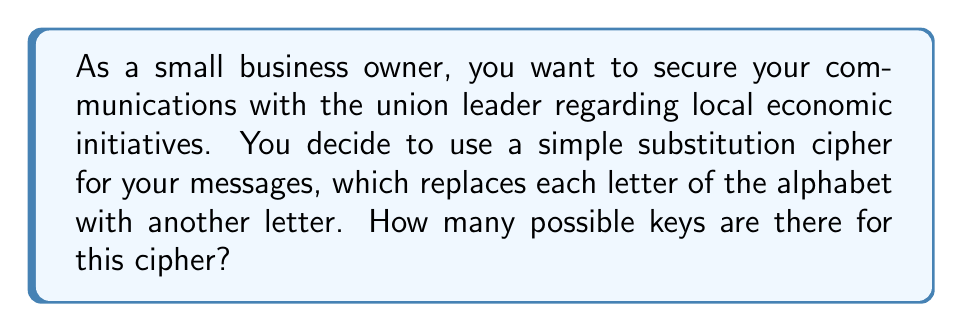Give your solution to this math problem. Let's approach this step-by-step:

1) In a simple substitution cipher, each letter of the alphabet is replaced by another letter.

2) We start with 26 letters in the English alphabet.

3) For the first letter, we have 26 choices.

4) For the second letter, we have 25 choices (because one letter has already been used).

5) For the third letter, we have 24 choices, and so on.

6) This pattern continues until we assign the last letter, for which we have only 1 choice.

7) The total number of possible keys is therefore the product of all these choices:

   $$26 \times 25 \times 24 \times 23 \times ... \times 2 \times 1$$

8) This is the definition of 26 factorial, denoted as 26!

9) We can calculate this:

   $$26! = 403,291,461,126,605,635,584,000,000$$

This extremely large number demonstrates why simple substitution ciphers, while easy to implement, can be secure for casual use in a small business setting.
Answer: $26!$ or 403,291,461,126,605,635,584,000,000 